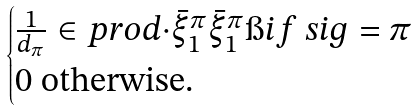Convert formula to latex. <formula><loc_0><loc_0><loc_500><loc_500>\begin{cases} \frac { 1 } { d _ { \pi } } \in p r o d { \cdot } { \bar { \xi } ^ { \pi } _ { 1 } } \bar { \xi } ^ { \pi } _ { 1 } \i i f \ s i g = \pi \\ 0 \text { otherwise.} \end{cases}</formula> 